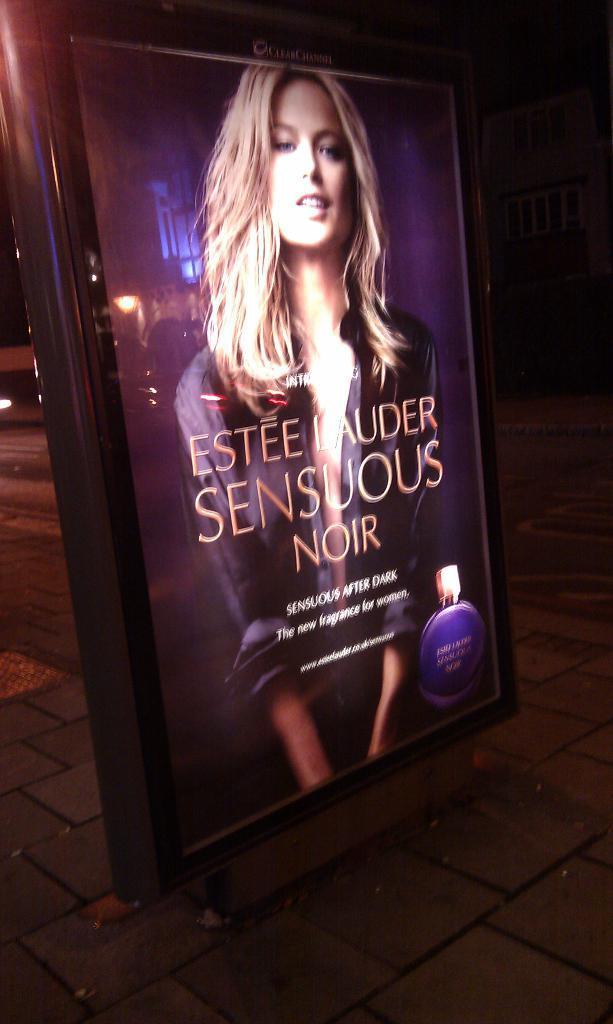Please provide a concise description of this image. This is the picture of a road. In the foreground there is a board. On the board there is a picture of a woman and there is text and there is a picture of a bottle. At the back there is a building. At the bottom there is a road and there is a footpath. 